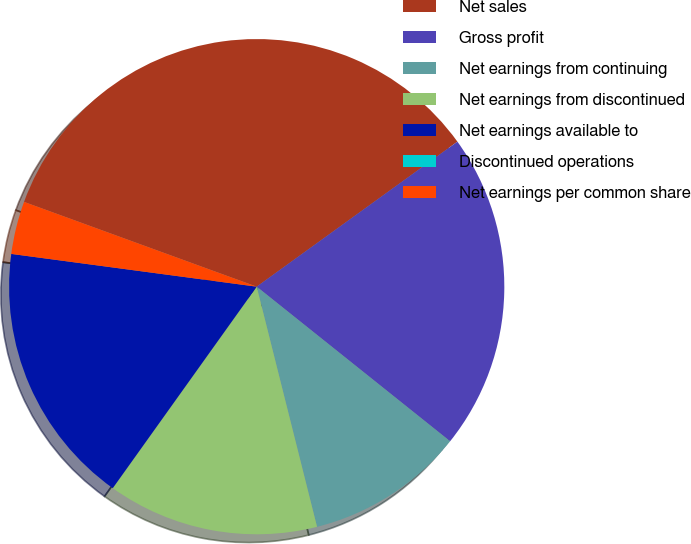<chart> <loc_0><loc_0><loc_500><loc_500><pie_chart><fcel>Net sales<fcel>Gross profit<fcel>Net earnings from continuing<fcel>Net earnings from discontinued<fcel>Net earnings available to<fcel>Discontinued operations<fcel>Net earnings per common share<nl><fcel>34.48%<fcel>20.69%<fcel>10.35%<fcel>13.79%<fcel>17.24%<fcel>0.0%<fcel>3.45%<nl></chart> 